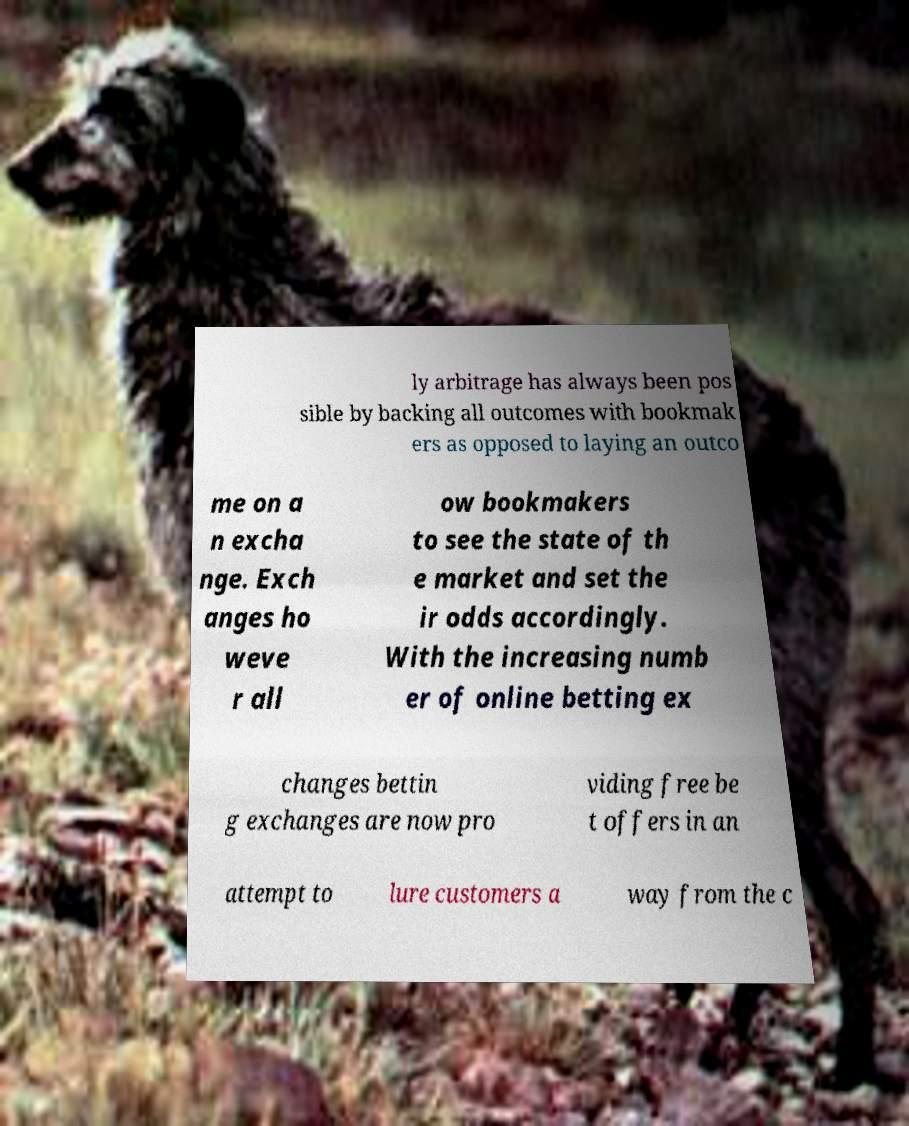There's text embedded in this image that I need extracted. Can you transcribe it verbatim? ly arbitrage has always been pos sible by backing all outcomes with bookmak ers as opposed to laying an outco me on a n excha nge. Exch anges ho weve r all ow bookmakers to see the state of th e market and set the ir odds accordingly. With the increasing numb er of online betting ex changes bettin g exchanges are now pro viding free be t offers in an attempt to lure customers a way from the c 